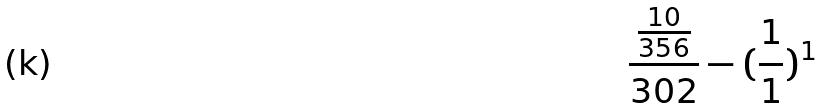<formula> <loc_0><loc_0><loc_500><loc_500>\frac { \frac { 1 0 } { 3 5 6 } } { 3 0 2 } - ( \frac { 1 } { 1 } ) ^ { 1 }</formula> 